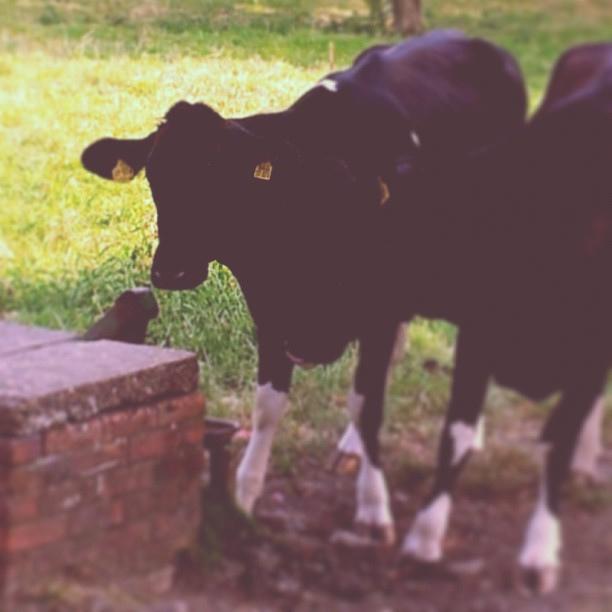What is the cow standing behind?
Give a very brief answer. Wall. What do the tags on the cows mean?
Give a very brief answer. Ownership. What is the cow on the left looking at?
Short answer required. Bricks. Is there fresh grass for the cows to eat?
Concise answer only. Yes. How many cows are there?
Quick response, please. 2. 